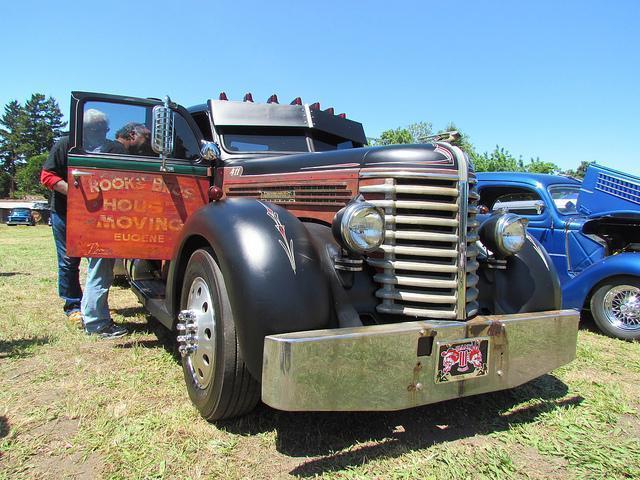These types of vehicles are commonly referred to as what?
Make your selection from the four choices given to correctly answer the question.
Options: Modern, vintage, contemporary, futuristic. Vintage. 